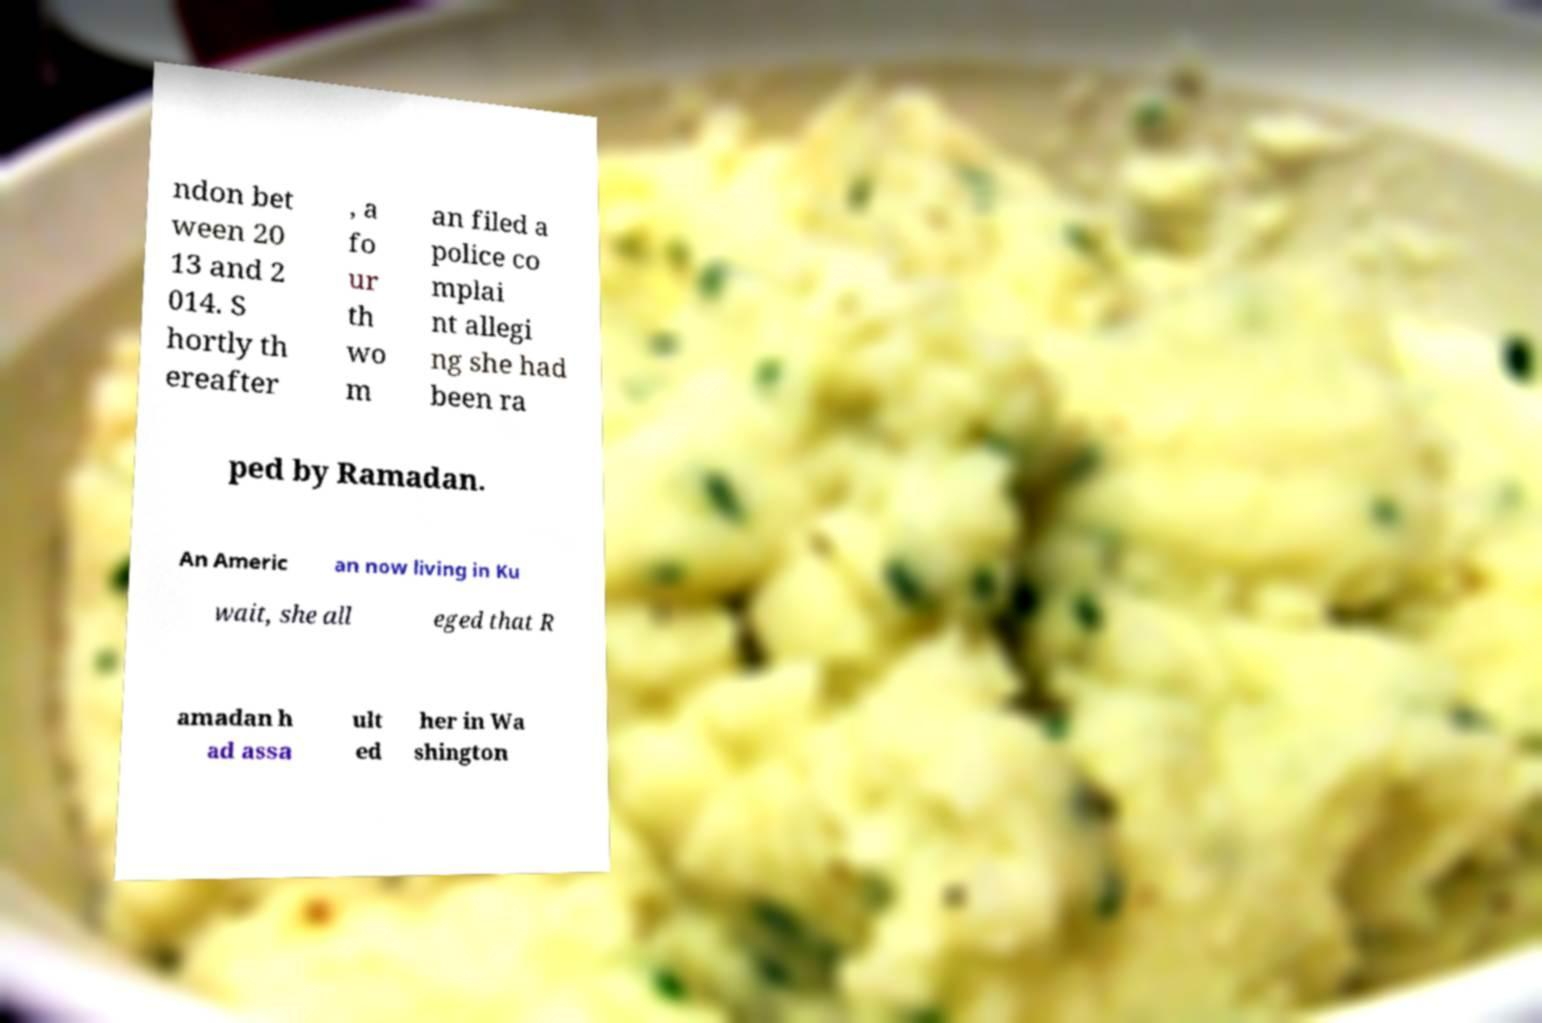I need the written content from this picture converted into text. Can you do that? ndon bet ween 20 13 and 2 014. S hortly th ereafter , a fo ur th wo m an filed a police co mplai nt allegi ng she had been ra ped by Ramadan. An Americ an now living in Ku wait, she all eged that R amadan h ad assa ult ed her in Wa shington 